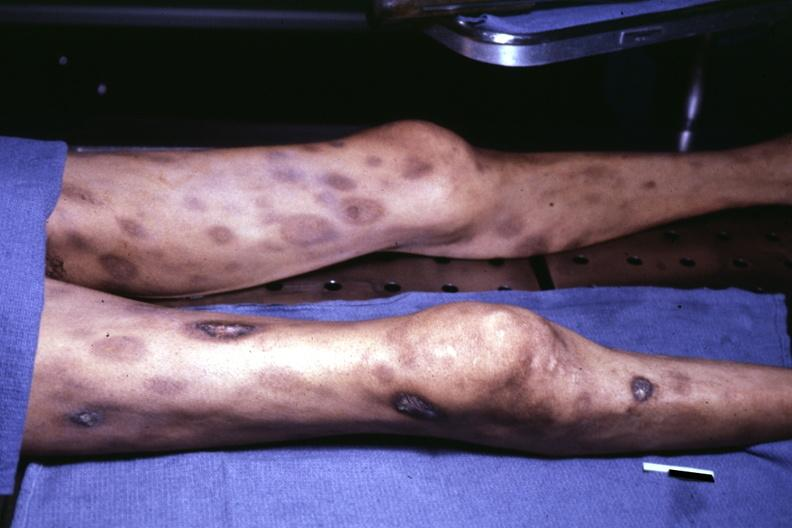what does this image show?
Answer the question using a single word or phrase. View of thighs and legs at autopsy ecchymoses with central necrosis and ulceration looks like pyoderma gangrenosum 